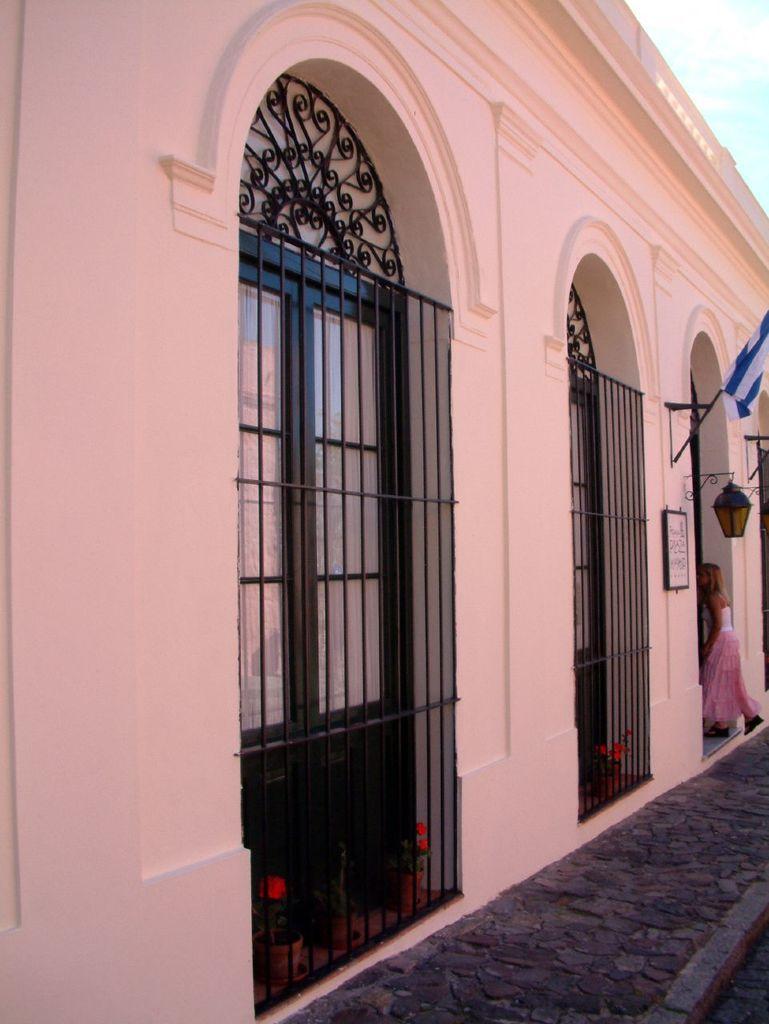In one or two sentences, can you explain what this image depicts? In this image we can see there is a building and there is a girl entering into the building, there is a flag on the building. In the background there is a sky. 